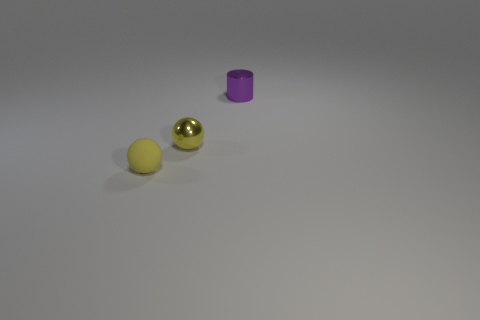How many yellow spheres must be subtracted to get 1 yellow spheres? 1 Add 3 shiny things. How many objects exist? 6 Subtract all cylinders. How many objects are left? 2 Subtract all small metallic cylinders. Subtract all small metallic cylinders. How many objects are left? 1 Add 1 small purple metallic cylinders. How many small purple metallic cylinders are left? 2 Add 2 small green things. How many small green things exist? 2 Subtract 0 red spheres. How many objects are left? 3 